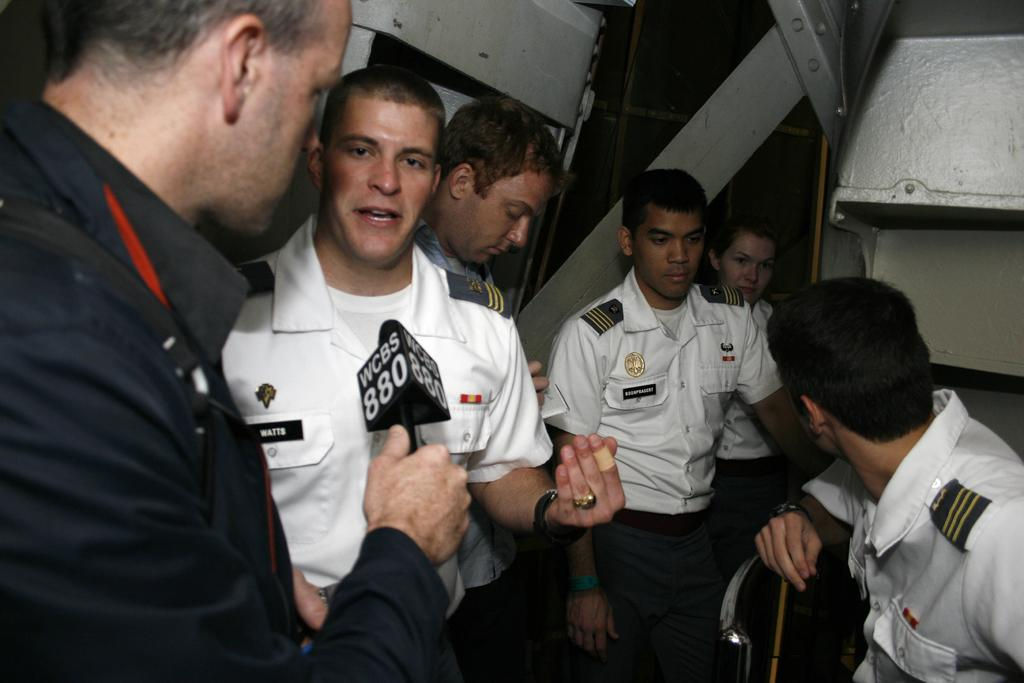How many people are in the image wearing uniforms? There are five persons in the image wearing uniforms. What is one person holding in their hand? One person is holding a microphone in their hand. What can be seen in the background of the image? Metal rods are visible in the background of the image. Where might this image have been taken? The image may have been taken in a building. Can you hear the person with the straw laughing in the image? There is no person with a straw in the image, nor is there any indication of laughter. 